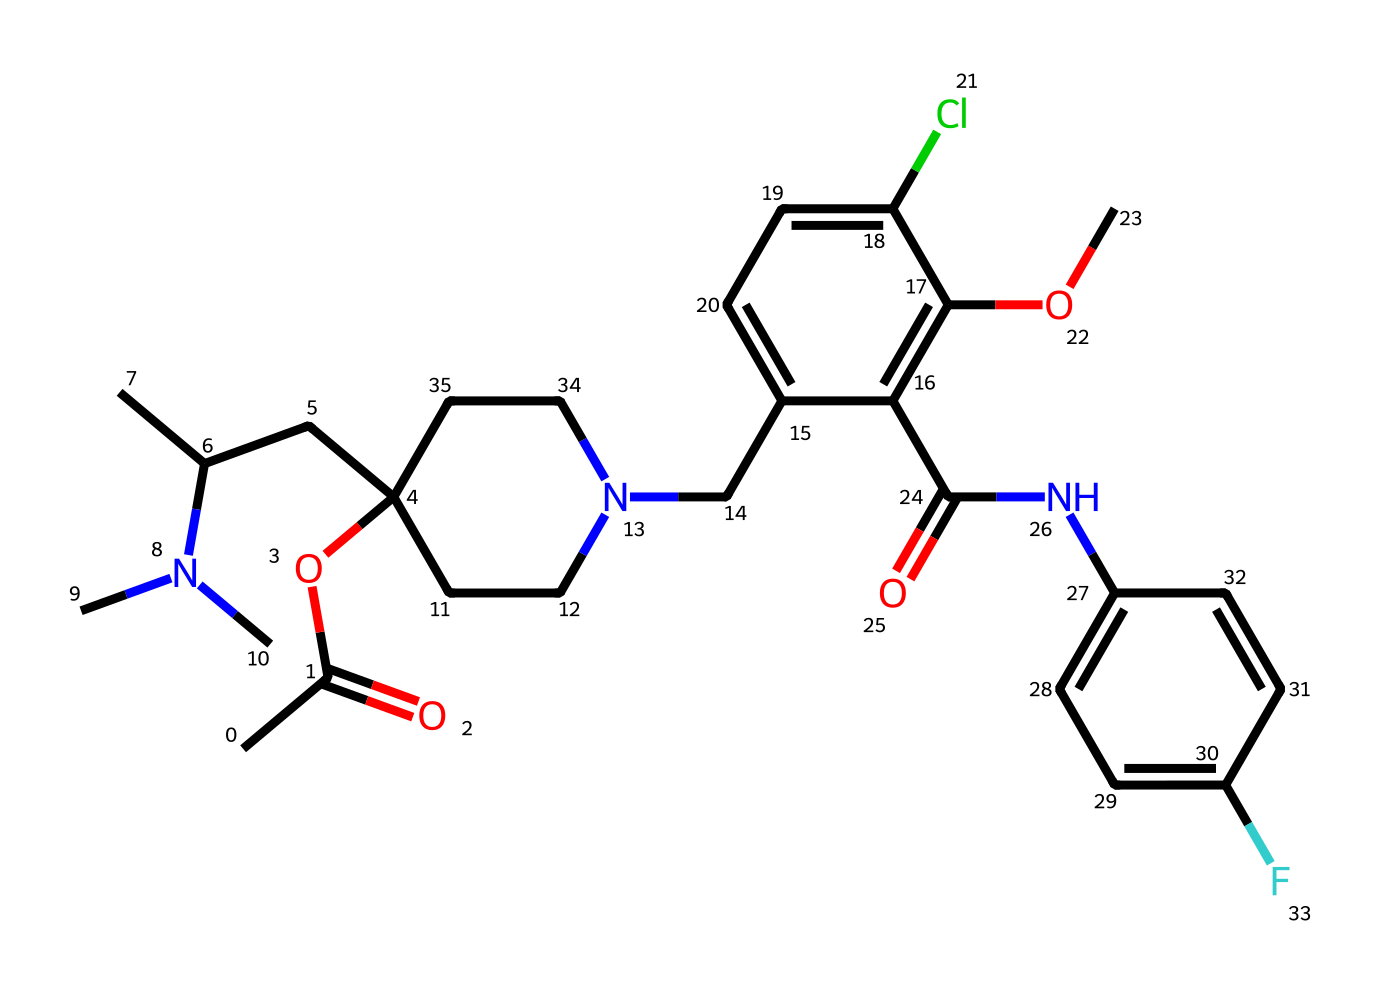What is the ester functional group in this compound? The ester functional group is characterized by a carbon atom double-bonded to an oxygen atom and single-bonded to another oxygen atom (RCOOR'). In this SMILES representation, the part "CC(=O)O" indicates the presence of the ester.
Answer: CC(=O)O How many nitrogen atoms are present in this structure? By examining the SMILES notation, we can identify the presence of nitrogen atoms by counting the "N" present in the structure. There are a total of three "N" in the representation.
Answer: 3 What type of reaction is typically used to form esters? The common reaction to form esters is called esterification, which typically involves the reaction of an alcohol with a carboxylic acid. This reaction results in the formation of an ester and water.
Answer: esterification Which elements are present in the ester portion of the structure? The ester portion consists of carbon (C), hydrogen (H), and oxygen (O) atoms. Analyzing "CC(=O)O" shows these three elements are indeed present.
Answer: carbon, hydrogen, oxygen What is the degree of saturation in this molecule? The degree of saturation refers to the number of rings and multiple bonds in a molecule. This compound appears to contain multiple rings and double bonds, indicating that it is not fully saturated. To determine the exact saturation, we must analyze the structure, but it can be said that it has multiple unsaturations.
Answer: not fully saturated What role do ester groups play in this leukemia treatment drug? Esters can enhance the pharmacokinetics of drugs by improving their solubility and bioavailability, which is crucial for the effectiveness of a chemotherapy drug. The presence of an ester group in the structure suggests that it serves this purpose.
Answer: improve solubility and bioavailability 